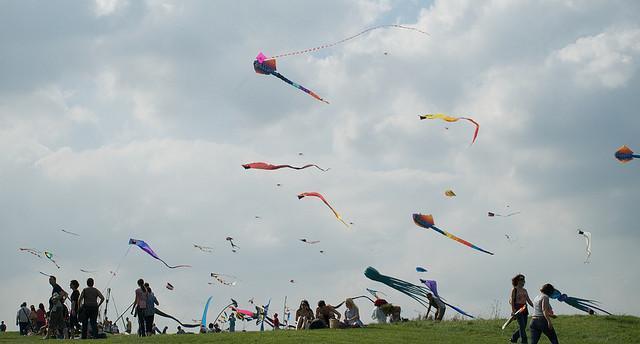How many clear bottles are there in the image?
Give a very brief answer. 0. 